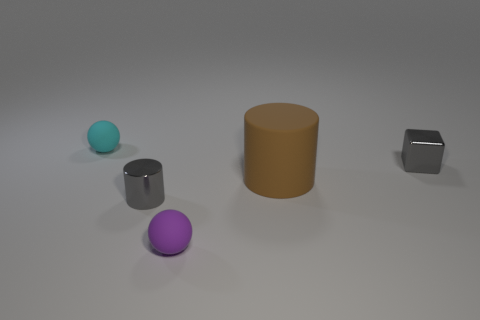Are there fewer gray objects behind the big object than tiny objects in front of the tiny metallic cube?
Your answer should be compact. Yes. There is a matte thing that is on the left side of the large brown cylinder and in front of the tiny gray cube; what is its shape?
Give a very brief answer. Sphere. What number of tiny gray shiny things have the same shape as the brown thing?
Offer a terse response. 1. There is a purple sphere that is the same material as the big brown object; what is its size?
Provide a short and direct response. Small. Are there more tiny brown objects than big rubber cylinders?
Your answer should be compact. No. What color is the tiny thing on the right side of the purple object?
Your response must be concise. Gray. How big is the object that is both to the left of the purple rubber sphere and in front of the big brown thing?
Provide a succinct answer. Small. How many brown rubber cylinders are the same size as the brown rubber object?
Offer a very short reply. 0. There is a gray object that is the same shape as the large brown object; what is it made of?
Offer a terse response. Metal. Is the tiny cyan thing the same shape as the big brown object?
Your answer should be very brief. No. 